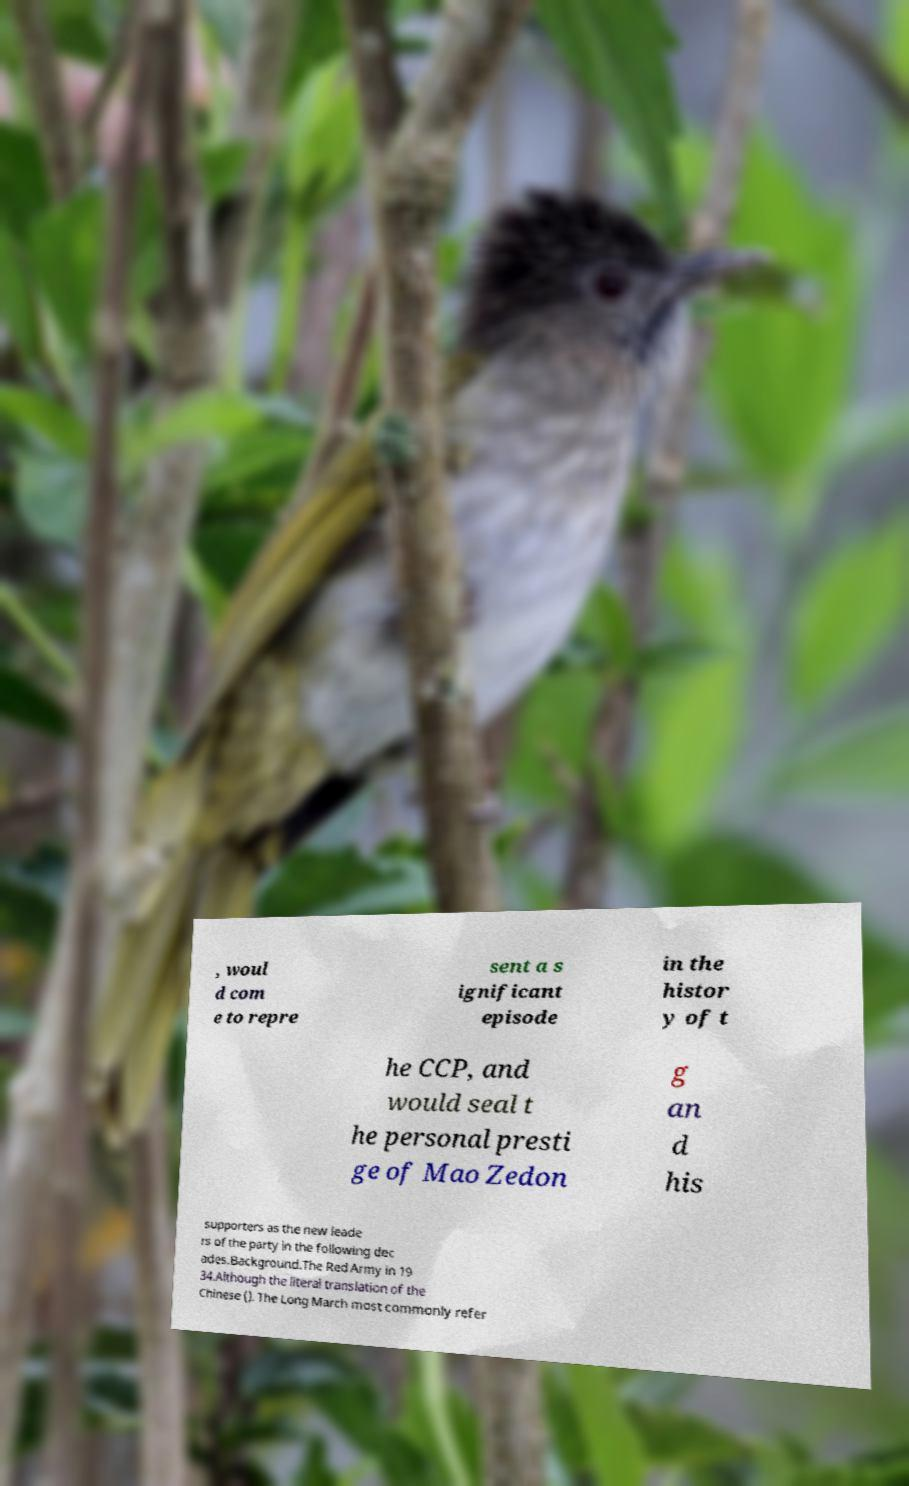What messages or text are displayed in this image? I need them in a readable, typed format. , woul d com e to repre sent a s ignificant episode in the histor y of t he CCP, and would seal t he personal presti ge of Mao Zedon g an d his supporters as the new leade rs of the party in the following dec ades.Background.The Red Army in 19 34.Although the literal translation of the Chinese (). The Long March most commonly refer 